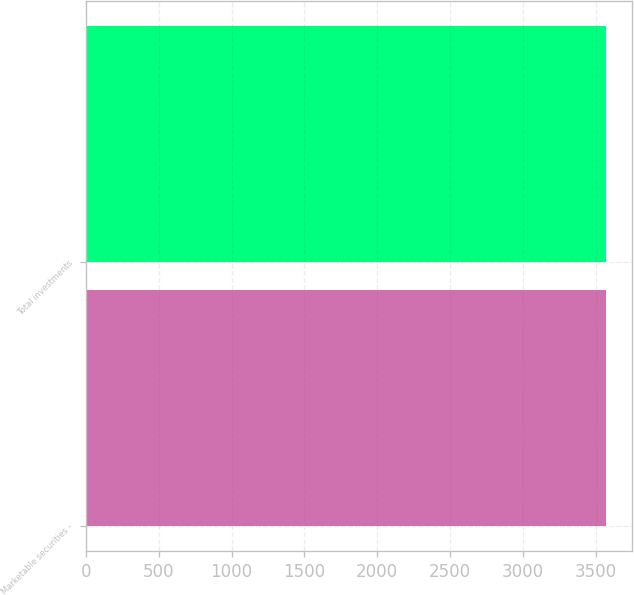<chart> <loc_0><loc_0><loc_500><loc_500><bar_chart><fcel>Marketable securities -<fcel>Total investments<nl><fcel>3572<fcel>3572.1<nl></chart> 